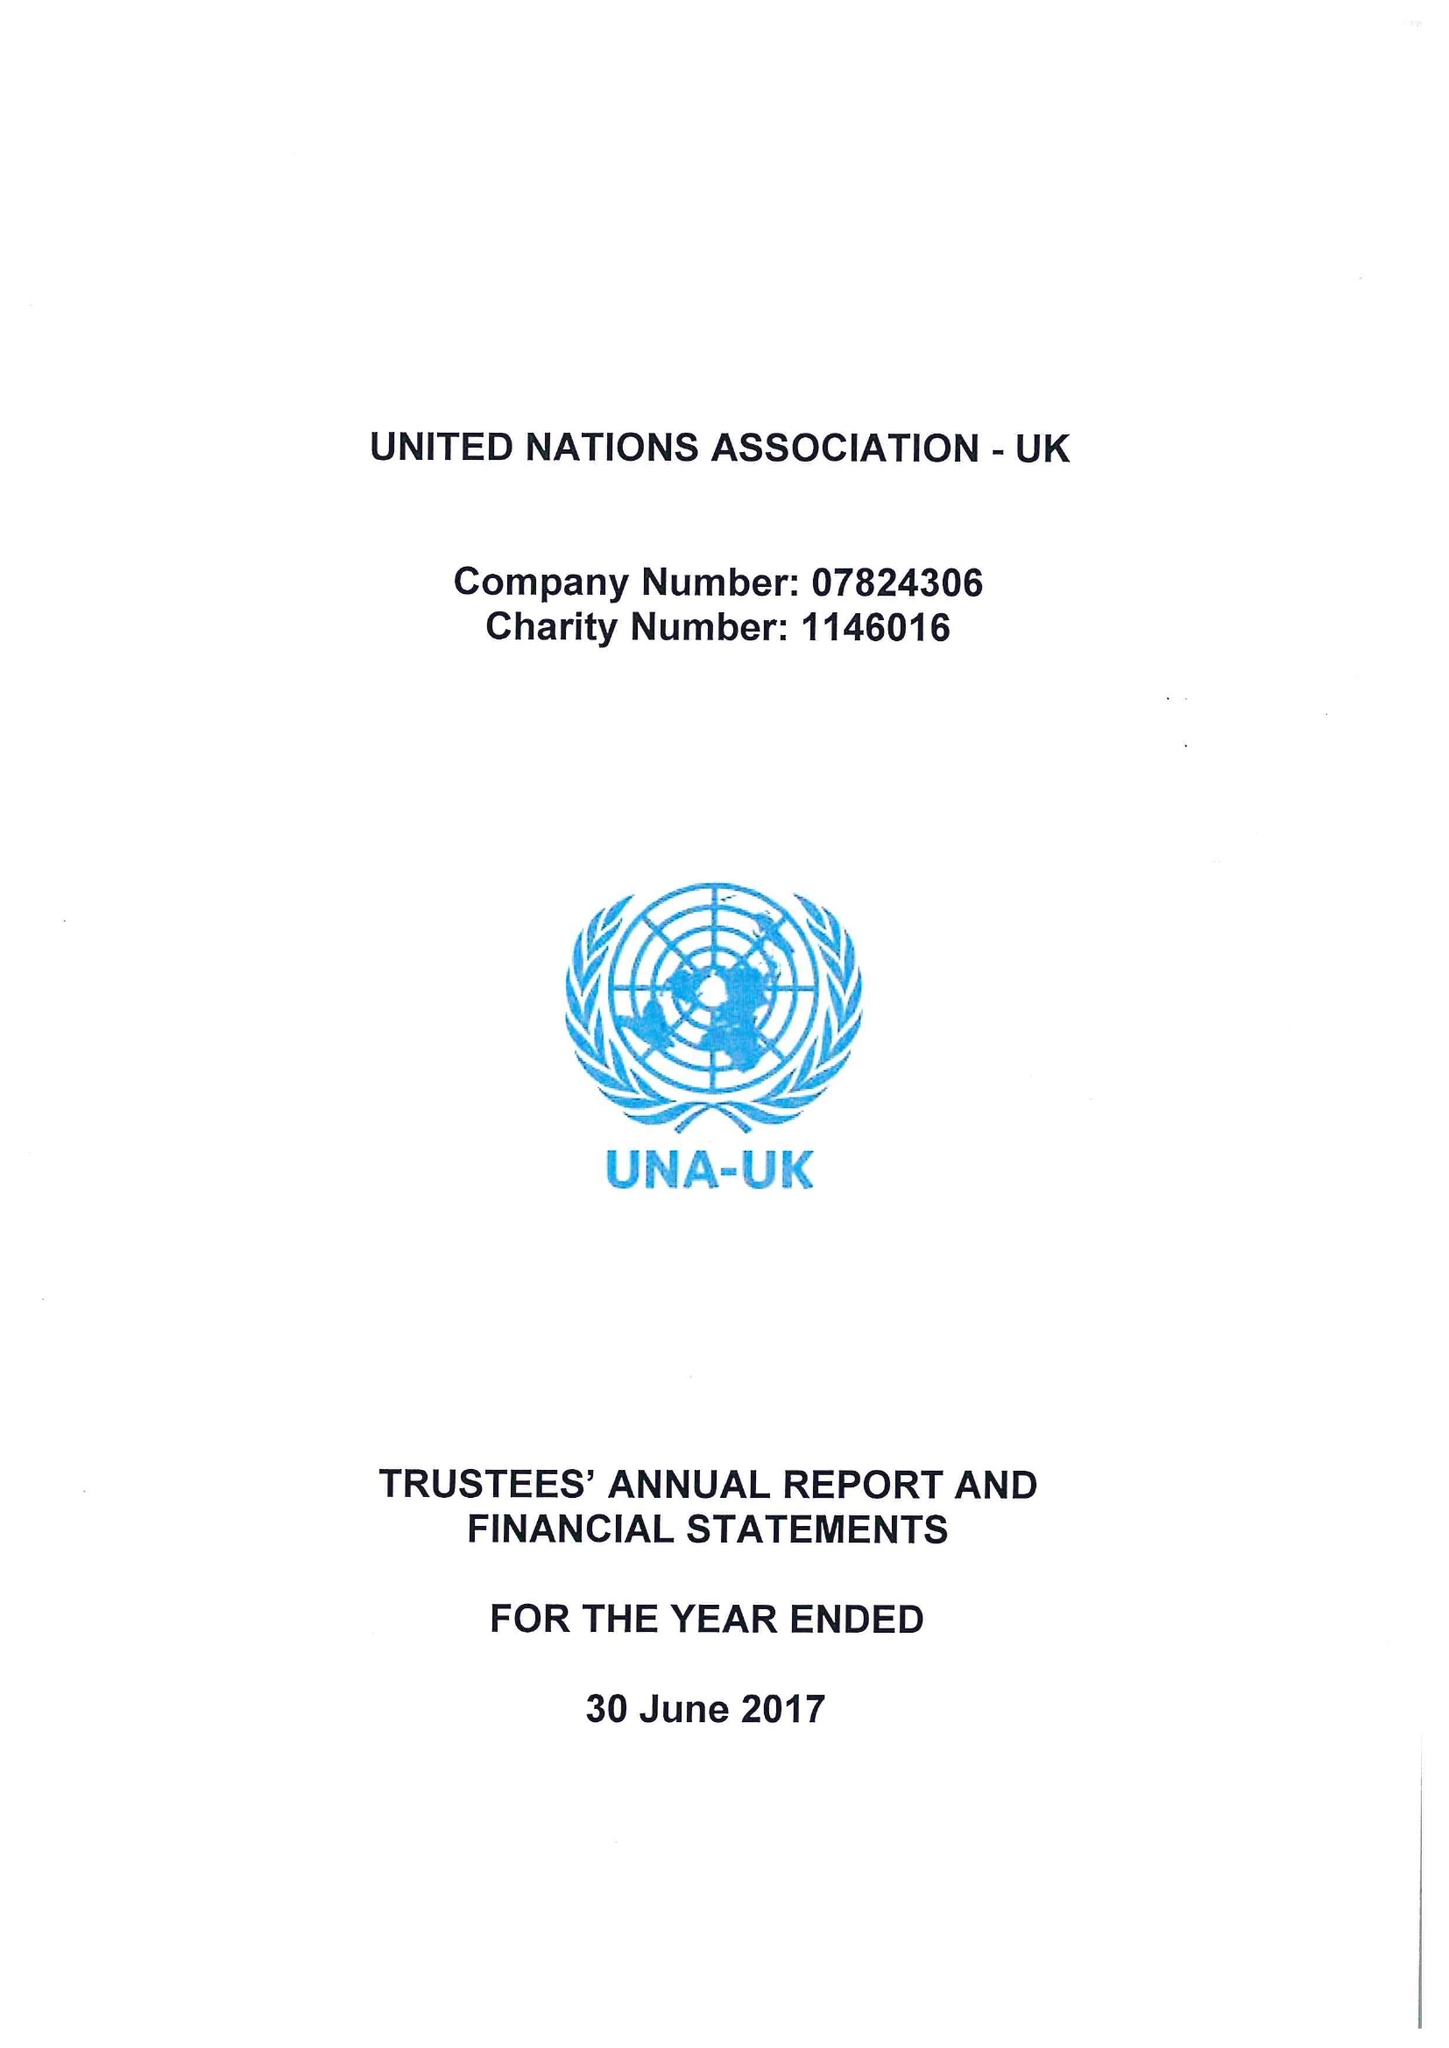What is the value for the address__street_line?
Answer the question using a single word or phrase. 3 WHITEHALL COURT 